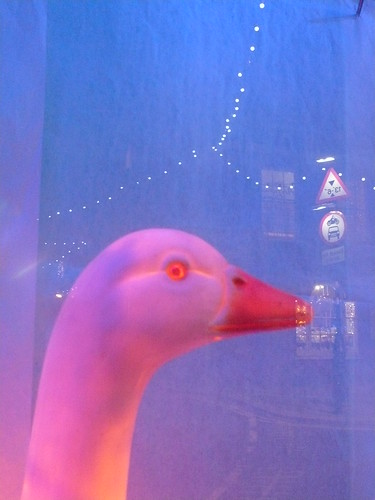Your goal is to classify the image based on its domain, which can be 'videogame', 'painting', 'sketch', 'cartoon', 'art', 'toy', 'deviantart', 'graphic', 'sculpture', 'misc', 'embroidery', 'sticker', 'graffiti', 'origami', or 'tattoo'. Your final output should specify the identified domain of the image. Upon observing the image, the appropriate domain classification is 'toy'. The object depicted resembles a realistic animal, specifically a goose, and is made from materials typically used in toy manufacturing. The presence of artificial elements and a possibly thematic background with a caution sign indicates that this item is designed for entertainment or decorative purposes, such as part of a larger playset or as an individual collector's item. The setting and object don't correlate with other domains like 'painting' or 'videogame', which would suggest a digital or artistic rendering rather than a physical object. 